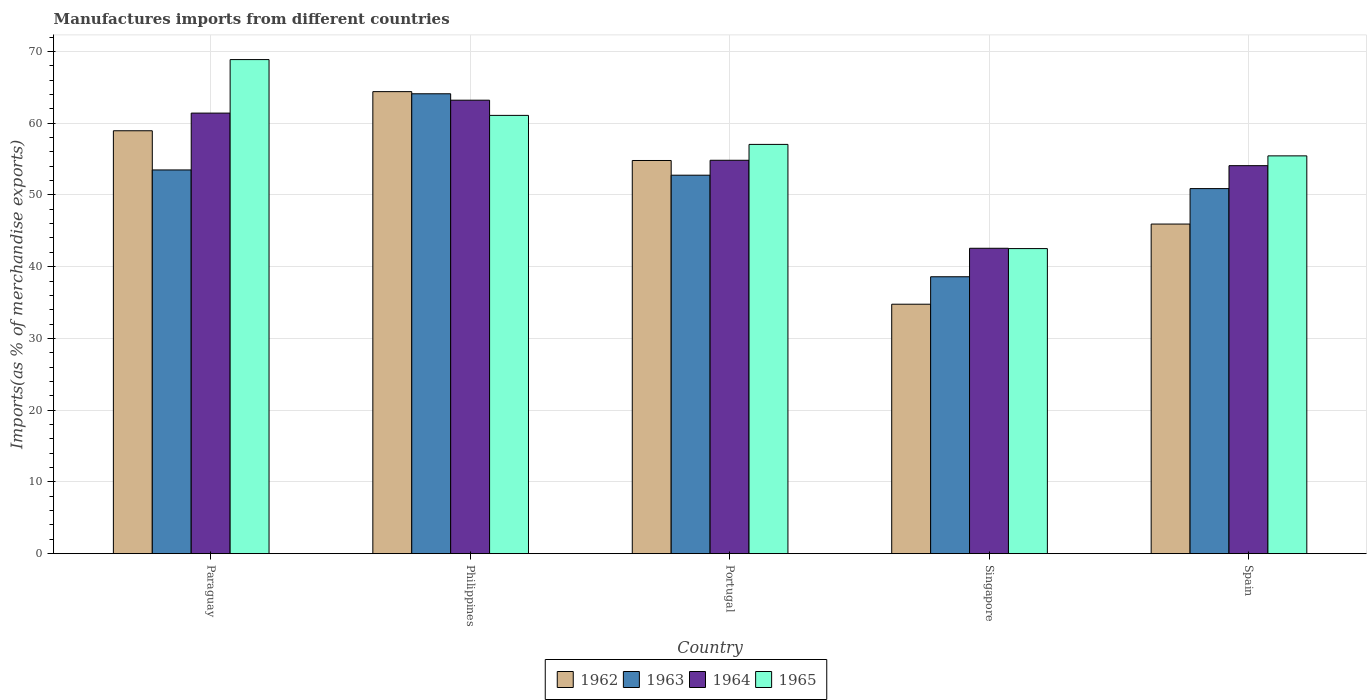How many different coloured bars are there?
Offer a very short reply. 4. How many groups of bars are there?
Keep it short and to the point. 5. Are the number of bars on each tick of the X-axis equal?
Give a very brief answer. Yes. How many bars are there on the 1st tick from the right?
Keep it short and to the point. 4. What is the label of the 5th group of bars from the left?
Provide a succinct answer. Spain. What is the percentage of imports to different countries in 1963 in Spain?
Your answer should be very brief. 50.88. Across all countries, what is the maximum percentage of imports to different countries in 1962?
Offer a terse response. 64.4. Across all countries, what is the minimum percentage of imports to different countries in 1963?
Ensure brevity in your answer.  38.6. In which country was the percentage of imports to different countries in 1965 maximum?
Give a very brief answer. Paraguay. In which country was the percentage of imports to different countries in 1964 minimum?
Offer a terse response. Singapore. What is the total percentage of imports to different countries in 1964 in the graph?
Offer a terse response. 276.08. What is the difference between the percentage of imports to different countries in 1963 in Portugal and that in Singapore?
Give a very brief answer. 14.16. What is the difference between the percentage of imports to different countries in 1964 in Singapore and the percentage of imports to different countries in 1963 in Portugal?
Ensure brevity in your answer.  -10.19. What is the average percentage of imports to different countries in 1962 per country?
Make the answer very short. 51.77. What is the difference between the percentage of imports to different countries of/in 1964 and percentage of imports to different countries of/in 1962 in Portugal?
Offer a very short reply. 0.03. In how many countries, is the percentage of imports to different countries in 1964 greater than 46 %?
Your answer should be very brief. 4. What is the ratio of the percentage of imports to different countries in 1963 in Portugal to that in Singapore?
Keep it short and to the point. 1.37. What is the difference between the highest and the second highest percentage of imports to different countries in 1965?
Provide a succinct answer. -11.82. What is the difference between the highest and the lowest percentage of imports to different countries in 1963?
Give a very brief answer. 25.5. In how many countries, is the percentage of imports to different countries in 1963 greater than the average percentage of imports to different countries in 1963 taken over all countries?
Your answer should be compact. 3. What does the 1st bar from the left in Philippines represents?
Provide a succinct answer. 1962. What does the 2nd bar from the right in Portugal represents?
Give a very brief answer. 1964. How many bars are there?
Offer a very short reply. 20. How many countries are there in the graph?
Offer a very short reply. 5. Are the values on the major ticks of Y-axis written in scientific E-notation?
Offer a very short reply. No. Does the graph contain any zero values?
Make the answer very short. No. Does the graph contain grids?
Provide a succinct answer. Yes. What is the title of the graph?
Offer a very short reply. Manufactures imports from different countries. Does "1989" appear as one of the legend labels in the graph?
Your answer should be compact. No. What is the label or title of the X-axis?
Your answer should be very brief. Country. What is the label or title of the Y-axis?
Make the answer very short. Imports(as % of merchandise exports). What is the Imports(as % of merchandise exports) in 1962 in Paraguay?
Offer a terse response. 58.94. What is the Imports(as % of merchandise exports) of 1963 in Paraguay?
Provide a succinct answer. 53.48. What is the Imports(as % of merchandise exports) of 1964 in Paraguay?
Offer a very short reply. 61.4. What is the Imports(as % of merchandise exports) in 1965 in Paraguay?
Keep it short and to the point. 68.86. What is the Imports(as % of merchandise exports) in 1962 in Philippines?
Provide a short and direct response. 64.4. What is the Imports(as % of merchandise exports) in 1963 in Philippines?
Your response must be concise. 64.1. What is the Imports(as % of merchandise exports) in 1964 in Philippines?
Your response must be concise. 63.2. What is the Imports(as % of merchandise exports) of 1965 in Philippines?
Offer a terse response. 61.09. What is the Imports(as % of merchandise exports) of 1962 in Portugal?
Offer a very short reply. 54.8. What is the Imports(as % of merchandise exports) of 1963 in Portugal?
Your answer should be compact. 52.75. What is the Imports(as % of merchandise exports) in 1964 in Portugal?
Provide a succinct answer. 54.83. What is the Imports(as % of merchandise exports) in 1965 in Portugal?
Keep it short and to the point. 57.04. What is the Imports(as % of merchandise exports) in 1962 in Singapore?
Offer a terse response. 34.77. What is the Imports(as % of merchandise exports) in 1963 in Singapore?
Give a very brief answer. 38.6. What is the Imports(as % of merchandise exports) of 1964 in Singapore?
Your answer should be very brief. 42.56. What is the Imports(as % of merchandise exports) of 1965 in Singapore?
Ensure brevity in your answer.  42.52. What is the Imports(as % of merchandise exports) of 1962 in Spain?
Your response must be concise. 45.94. What is the Imports(as % of merchandise exports) in 1963 in Spain?
Your answer should be very brief. 50.88. What is the Imports(as % of merchandise exports) of 1964 in Spain?
Provide a short and direct response. 54.08. What is the Imports(as % of merchandise exports) of 1965 in Spain?
Your answer should be very brief. 55.44. Across all countries, what is the maximum Imports(as % of merchandise exports) of 1962?
Ensure brevity in your answer.  64.4. Across all countries, what is the maximum Imports(as % of merchandise exports) of 1963?
Your response must be concise. 64.1. Across all countries, what is the maximum Imports(as % of merchandise exports) in 1964?
Your response must be concise. 63.2. Across all countries, what is the maximum Imports(as % of merchandise exports) in 1965?
Give a very brief answer. 68.86. Across all countries, what is the minimum Imports(as % of merchandise exports) of 1962?
Offer a terse response. 34.77. Across all countries, what is the minimum Imports(as % of merchandise exports) of 1963?
Your response must be concise. 38.6. Across all countries, what is the minimum Imports(as % of merchandise exports) in 1964?
Offer a very short reply. 42.56. Across all countries, what is the minimum Imports(as % of merchandise exports) in 1965?
Give a very brief answer. 42.52. What is the total Imports(as % of merchandise exports) of 1962 in the graph?
Keep it short and to the point. 258.85. What is the total Imports(as % of merchandise exports) of 1963 in the graph?
Ensure brevity in your answer.  259.81. What is the total Imports(as % of merchandise exports) of 1964 in the graph?
Provide a short and direct response. 276.08. What is the total Imports(as % of merchandise exports) of 1965 in the graph?
Give a very brief answer. 284.96. What is the difference between the Imports(as % of merchandise exports) of 1962 in Paraguay and that in Philippines?
Provide a short and direct response. -5.45. What is the difference between the Imports(as % of merchandise exports) in 1963 in Paraguay and that in Philippines?
Ensure brevity in your answer.  -10.62. What is the difference between the Imports(as % of merchandise exports) of 1964 in Paraguay and that in Philippines?
Your response must be concise. -1.8. What is the difference between the Imports(as % of merchandise exports) in 1965 in Paraguay and that in Philippines?
Your response must be concise. 7.78. What is the difference between the Imports(as % of merchandise exports) in 1962 in Paraguay and that in Portugal?
Make the answer very short. 4.15. What is the difference between the Imports(as % of merchandise exports) in 1963 in Paraguay and that in Portugal?
Provide a succinct answer. 0.73. What is the difference between the Imports(as % of merchandise exports) in 1964 in Paraguay and that in Portugal?
Offer a very short reply. 6.57. What is the difference between the Imports(as % of merchandise exports) in 1965 in Paraguay and that in Portugal?
Provide a short and direct response. 11.82. What is the difference between the Imports(as % of merchandise exports) in 1962 in Paraguay and that in Singapore?
Your response must be concise. 24.17. What is the difference between the Imports(as % of merchandise exports) of 1963 in Paraguay and that in Singapore?
Your answer should be compact. 14.89. What is the difference between the Imports(as % of merchandise exports) of 1964 in Paraguay and that in Singapore?
Your answer should be compact. 18.84. What is the difference between the Imports(as % of merchandise exports) of 1965 in Paraguay and that in Singapore?
Offer a very short reply. 26.34. What is the difference between the Imports(as % of merchandise exports) of 1962 in Paraguay and that in Spain?
Provide a succinct answer. 13. What is the difference between the Imports(as % of merchandise exports) in 1963 in Paraguay and that in Spain?
Your answer should be very brief. 2.6. What is the difference between the Imports(as % of merchandise exports) of 1964 in Paraguay and that in Spain?
Offer a terse response. 7.33. What is the difference between the Imports(as % of merchandise exports) of 1965 in Paraguay and that in Spain?
Provide a succinct answer. 13.42. What is the difference between the Imports(as % of merchandise exports) in 1962 in Philippines and that in Portugal?
Provide a short and direct response. 9.6. What is the difference between the Imports(as % of merchandise exports) of 1963 in Philippines and that in Portugal?
Provide a succinct answer. 11.35. What is the difference between the Imports(as % of merchandise exports) of 1964 in Philippines and that in Portugal?
Keep it short and to the point. 8.37. What is the difference between the Imports(as % of merchandise exports) of 1965 in Philippines and that in Portugal?
Make the answer very short. 4.04. What is the difference between the Imports(as % of merchandise exports) of 1962 in Philippines and that in Singapore?
Keep it short and to the point. 29.63. What is the difference between the Imports(as % of merchandise exports) of 1963 in Philippines and that in Singapore?
Provide a short and direct response. 25.5. What is the difference between the Imports(as % of merchandise exports) of 1964 in Philippines and that in Singapore?
Provide a succinct answer. 20.64. What is the difference between the Imports(as % of merchandise exports) in 1965 in Philippines and that in Singapore?
Give a very brief answer. 18.57. What is the difference between the Imports(as % of merchandise exports) in 1962 in Philippines and that in Spain?
Your answer should be compact. 18.46. What is the difference between the Imports(as % of merchandise exports) in 1963 in Philippines and that in Spain?
Your response must be concise. 13.22. What is the difference between the Imports(as % of merchandise exports) in 1964 in Philippines and that in Spain?
Your answer should be very brief. 9.12. What is the difference between the Imports(as % of merchandise exports) of 1965 in Philippines and that in Spain?
Offer a very short reply. 5.64. What is the difference between the Imports(as % of merchandise exports) of 1962 in Portugal and that in Singapore?
Your response must be concise. 20.03. What is the difference between the Imports(as % of merchandise exports) in 1963 in Portugal and that in Singapore?
Your answer should be very brief. 14.16. What is the difference between the Imports(as % of merchandise exports) in 1964 in Portugal and that in Singapore?
Give a very brief answer. 12.27. What is the difference between the Imports(as % of merchandise exports) of 1965 in Portugal and that in Singapore?
Your response must be concise. 14.52. What is the difference between the Imports(as % of merchandise exports) in 1962 in Portugal and that in Spain?
Ensure brevity in your answer.  8.86. What is the difference between the Imports(as % of merchandise exports) of 1963 in Portugal and that in Spain?
Your answer should be compact. 1.87. What is the difference between the Imports(as % of merchandise exports) in 1964 in Portugal and that in Spain?
Your answer should be very brief. 0.75. What is the difference between the Imports(as % of merchandise exports) of 1965 in Portugal and that in Spain?
Provide a succinct answer. 1.6. What is the difference between the Imports(as % of merchandise exports) of 1962 in Singapore and that in Spain?
Your response must be concise. -11.17. What is the difference between the Imports(as % of merchandise exports) of 1963 in Singapore and that in Spain?
Provide a succinct answer. -12.29. What is the difference between the Imports(as % of merchandise exports) in 1964 in Singapore and that in Spain?
Offer a very short reply. -11.51. What is the difference between the Imports(as % of merchandise exports) in 1965 in Singapore and that in Spain?
Make the answer very short. -12.92. What is the difference between the Imports(as % of merchandise exports) in 1962 in Paraguay and the Imports(as % of merchandise exports) in 1963 in Philippines?
Provide a short and direct response. -5.15. What is the difference between the Imports(as % of merchandise exports) of 1962 in Paraguay and the Imports(as % of merchandise exports) of 1964 in Philippines?
Your answer should be compact. -4.26. What is the difference between the Imports(as % of merchandise exports) of 1962 in Paraguay and the Imports(as % of merchandise exports) of 1965 in Philippines?
Your answer should be compact. -2.14. What is the difference between the Imports(as % of merchandise exports) of 1963 in Paraguay and the Imports(as % of merchandise exports) of 1964 in Philippines?
Provide a succinct answer. -9.72. What is the difference between the Imports(as % of merchandise exports) of 1963 in Paraguay and the Imports(as % of merchandise exports) of 1965 in Philippines?
Offer a terse response. -7.61. What is the difference between the Imports(as % of merchandise exports) of 1964 in Paraguay and the Imports(as % of merchandise exports) of 1965 in Philippines?
Offer a very short reply. 0.32. What is the difference between the Imports(as % of merchandise exports) in 1962 in Paraguay and the Imports(as % of merchandise exports) in 1963 in Portugal?
Keep it short and to the point. 6.19. What is the difference between the Imports(as % of merchandise exports) of 1962 in Paraguay and the Imports(as % of merchandise exports) of 1964 in Portugal?
Ensure brevity in your answer.  4.11. What is the difference between the Imports(as % of merchandise exports) in 1962 in Paraguay and the Imports(as % of merchandise exports) in 1965 in Portugal?
Offer a terse response. 1.9. What is the difference between the Imports(as % of merchandise exports) of 1963 in Paraguay and the Imports(as % of merchandise exports) of 1964 in Portugal?
Give a very brief answer. -1.35. What is the difference between the Imports(as % of merchandise exports) of 1963 in Paraguay and the Imports(as % of merchandise exports) of 1965 in Portugal?
Your response must be concise. -3.56. What is the difference between the Imports(as % of merchandise exports) in 1964 in Paraguay and the Imports(as % of merchandise exports) in 1965 in Portugal?
Ensure brevity in your answer.  4.36. What is the difference between the Imports(as % of merchandise exports) of 1962 in Paraguay and the Imports(as % of merchandise exports) of 1963 in Singapore?
Make the answer very short. 20.35. What is the difference between the Imports(as % of merchandise exports) in 1962 in Paraguay and the Imports(as % of merchandise exports) in 1964 in Singapore?
Give a very brief answer. 16.38. What is the difference between the Imports(as % of merchandise exports) of 1962 in Paraguay and the Imports(as % of merchandise exports) of 1965 in Singapore?
Your answer should be very brief. 16.42. What is the difference between the Imports(as % of merchandise exports) in 1963 in Paraguay and the Imports(as % of merchandise exports) in 1964 in Singapore?
Make the answer very short. 10.92. What is the difference between the Imports(as % of merchandise exports) of 1963 in Paraguay and the Imports(as % of merchandise exports) of 1965 in Singapore?
Ensure brevity in your answer.  10.96. What is the difference between the Imports(as % of merchandise exports) in 1964 in Paraguay and the Imports(as % of merchandise exports) in 1965 in Singapore?
Keep it short and to the point. 18.88. What is the difference between the Imports(as % of merchandise exports) of 1962 in Paraguay and the Imports(as % of merchandise exports) of 1963 in Spain?
Offer a very short reply. 8.06. What is the difference between the Imports(as % of merchandise exports) in 1962 in Paraguay and the Imports(as % of merchandise exports) in 1964 in Spain?
Your answer should be very brief. 4.87. What is the difference between the Imports(as % of merchandise exports) in 1962 in Paraguay and the Imports(as % of merchandise exports) in 1965 in Spain?
Offer a terse response. 3.5. What is the difference between the Imports(as % of merchandise exports) of 1963 in Paraguay and the Imports(as % of merchandise exports) of 1964 in Spain?
Provide a succinct answer. -0.6. What is the difference between the Imports(as % of merchandise exports) of 1963 in Paraguay and the Imports(as % of merchandise exports) of 1965 in Spain?
Your answer should be compact. -1.96. What is the difference between the Imports(as % of merchandise exports) in 1964 in Paraguay and the Imports(as % of merchandise exports) in 1965 in Spain?
Your answer should be very brief. 5.96. What is the difference between the Imports(as % of merchandise exports) of 1962 in Philippines and the Imports(as % of merchandise exports) of 1963 in Portugal?
Your answer should be very brief. 11.65. What is the difference between the Imports(as % of merchandise exports) of 1962 in Philippines and the Imports(as % of merchandise exports) of 1964 in Portugal?
Give a very brief answer. 9.57. What is the difference between the Imports(as % of merchandise exports) in 1962 in Philippines and the Imports(as % of merchandise exports) in 1965 in Portugal?
Your response must be concise. 7.35. What is the difference between the Imports(as % of merchandise exports) of 1963 in Philippines and the Imports(as % of merchandise exports) of 1964 in Portugal?
Offer a terse response. 9.27. What is the difference between the Imports(as % of merchandise exports) of 1963 in Philippines and the Imports(as % of merchandise exports) of 1965 in Portugal?
Give a very brief answer. 7.05. What is the difference between the Imports(as % of merchandise exports) of 1964 in Philippines and the Imports(as % of merchandise exports) of 1965 in Portugal?
Your answer should be very brief. 6.16. What is the difference between the Imports(as % of merchandise exports) of 1962 in Philippines and the Imports(as % of merchandise exports) of 1963 in Singapore?
Give a very brief answer. 25.8. What is the difference between the Imports(as % of merchandise exports) in 1962 in Philippines and the Imports(as % of merchandise exports) in 1964 in Singapore?
Keep it short and to the point. 21.83. What is the difference between the Imports(as % of merchandise exports) of 1962 in Philippines and the Imports(as % of merchandise exports) of 1965 in Singapore?
Give a very brief answer. 21.87. What is the difference between the Imports(as % of merchandise exports) in 1963 in Philippines and the Imports(as % of merchandise exports) in 1964 in Singapore?
Your answer should be compact. 21.53. What is the difference between the Imports(as % of merchandise exports) in 1963 in Philippines and the Imports(as % of merchandise exports) in 1965 in Singapore?
Your answer should be very brief. 21.58. What is the difference between the Imports(as % of merchandise exports) of 1964 in Philippines and the Imports(as % of merchandise exports) of 1965 in Singapore?
Provide a short and direct response. 20.68. What is the difference between the Imports(as % of merchandise exports) of 1962 in Philippines and the Imports(as % of merchandise exports) of 1963 in Spain?
Your answer should be very brief. 13.51. What is the difference between the Imports(as % of merchandise exports) in 1962 in Philippines and the Imports(as % of merchandise exports) in 1964 in Spain?
Offer a very short reply. 10.32. What is the difference between the Imports(as % of merchandise exports) of 1962 in Philippines and the Imports(as % of merchandise exports) of 1965 in Spain?
Offer a very short reply. 8.95. What is the difference between the Imports(as % of merchandise exports) of 1963 in Philippines and the Imports(as % of merchandise exports) of 1964 in Spain?
Offer a very short reply. 10.02. What is the difference between the Imports(as % of merchandise exports) of 1963 in Philippines and the Imports(as % of merchandise exports) of 1965 in Spain?
Give a very brief answer. 8.65. What is the difference between the Imports(as % of merchandise exports) of 1964 in Philippines and the Imports(as % of merchandise exports) of 1965 in Spain?
Your response must be concise. 7.76. What is the difference between the Imports(as % of merchandise exports) of 1962 in Portugal and the Imports(as % of merchandise exports) of 1963 in Singapore?
Your answer should be very brief. 16.2. What is the difference between the Imports(as % of merchandise exports) in 1962 in Portugal and the Imports(as % of merchandise exports) in 1964 in Singapore?
Offer a very short reply. 12.23. What is the difference between the Imports(as % of merchandise exports) in 1962 in Portugal and the Imports(as % of merchandise exports) in 1965 in Singapore?
Offer a very short reply. 12.28. What is the difference between the Imports(as % of merchandise exports) of 1963 in Portugal and the Imports(as % of merchandise exports) of 1964 in Singapore?
Your answer should be very brief. 10.19. What is the difference between the Imports(as % of merchandise exports) of 1963 in Portugal and the Imports(as % of merchandise exports) of 1965 in Singapore?
Keep it short and to the point. 10.23. What is the difference between the Imports(as % of merchandise exports) in 1964 in Portugal and the Imports(as % of merchandise exports) in 1965 in Singapore?
Give a very brief answer. 12.31. What is the difference between the Imports(as % of merchandise exports) in 1962 in Portugal and the Imports(as % of merchandise exports) in 1963 in Spain?
Make the answer very short. 3.92. What is the difference between the Imports(as % of merchandise exports) in 1962 in Portugal and the Imports(as % of merchandise exports) in 1964 in Spain?
Ensure brevity in your answer.  0.72. What is the difference between the Imports(as % of merchandise exports) of 1962 in Portugal and the Imports(as % of merchandise exports) of 1965 in Spain?
Give a very brief answer. -0.65. What is the difference between the Imports(as % of merchandise exports) in 1963 in Portugal and the Imports(as % of merchandise exports) in 1964 in Spain?
Give a very brief answer. -1.33. What is the difference between the Imports(as % of merchandise exports) of 1963 in Portugal and the Imports(as % of merchandise exports) of 1965 in Spain?
Your answer should be compact. -2.69. What is the difference between the Imports(as % of merchandise exports) of 1964 in Portugal and the Imports(as % of merchandise exports) of 1965 in Spain?
Ensure brevity in your answer.  -0.61. What is the difference between the Imports(as % of merchandise exports) in 1962 in Singapore and the Imports(as % of merchandise exports) in 1963 in Spain?
Ensure brevity in your answer.  -16.11. What is the difference between the Imports(as % of merchandise exports) in 1962 in Singapore and the Imports(as % of merchandise exports) in 1964 in Spain?
Offer a terse response. -19.31. What is the difference between the Imports(as % of merchandise exports) of 1962 in Singapore and the Imports(as % of merchandise exports) of 1965 in Spain?
Your answer should be compact. -20.68. What is the difference between the Imports(as % of merchandise exports) of 1963 in Singapore and the Imports(as % of merchandise exports) of 1964 in Spain?
Your answer should be compact. -15.48. What is the difference between the Imports(as % of merchandise exports) in 1963 in Singapore and the Imports(as % of merchandise exports) in 1965 in Spain?
Offer a very short reply. -16.85. What is the difference between the Imports(as % of merchandise exports) in 1964 in Singapore and the Imports(as % of merchandise exports) in 1965 in Spain?
Provide a succinct answer. -12.88. What is the average Imports(as % of merchandise exports) of 1962 per country?
Provide a succinct answer. 51.77. What is the average Imports(as % of merchandise exports) in 1963 per country?
Make the answer very short. 51.96. What is the average Imports(as % of merchandise exports) in 1964 per country?
Ensure brevity in your answer.  55.22. What is the average Imports(as % of merchandise exports) of 1965 per country?
Your response must be concise. 56.99. What is the difference between the Imports(as % of merchandise exports) of 1962 and Imports(as % of merchandise exports) of 1963 in Paraguay?
Ensure brevity in your answer.  5.46. What is the difference between the Imports(as % of merchandise exports) of 1962 and Imports(as % of merchandise exports) of 1964 in Paraguay?
Offer a very short reply. -2.46. What is the difference between the Imports(as % of merchandise exports) of 1962 and Imports(as % of merchandise exports) of 1965 in Paraguay?
Your answer should be compact. -9.92. What is the difference between the Imports(as % of merchandise exports) of 1963 and Imports(as % of merchandise exports) of 1964 in Paraguay?
Ensure brevity in your answer.  -7.92. What is the difference between the Imports(as % of merchandise exports) of 1963 and Imports(as % of merchandise exports) of 1965 in Paraguay?
Offer a very short reply. -15.38. What is the difference between the Imports(as % of merchandise exports) in 1964 and Imports(as % of merchandise exports) in 1965 in Paraguay?
Your answer should be compact. -7.46. What is the difference between the Imports(as % of merchandise exports) in 1962 and Imports(as % of merchandise exports) in 1963 in Philippines?
Your answer should be compact. 0.3. What is the difference between the Imports(as % of merchandise exports) in 1962 and Imports(as % of merchandise exports) in 1964 in Philippines?
Give a very brief answer. 1.19. What is the difference between the Imports(as % of merchandise exports) of 1962 and Imports(as % of merchandise exports) of 1965 in Philippines?
Your answer should be compact. 3.31. What is the difference between the Imports(as % of merchandise exports) in 1963 and Imports(as % of merchandise exports) in 1964 in Philippines?
Your answer should be very brief. 0.89. What is the difference between the Imports(as % of merchandise exports) of 1963 and Imports(as % of merchandise exports) of 1965 in Philippines?
Offer a terse response. 3.01. What is the difference between the Imports(as % of merchandise exports) in 1964 and Imports(as % of merchandise exports) in 1965 in Philippines?
Give a very brief answer. 2.12. What is the difference between the Imports(as % of merchandise exports) in 1962 and Imports(as % of merchandise exports) in 1963 in Portugal?
Offer a terse response. 2.05. What is the difference between the Imports(as % of merchandise exports) of 1962 and Imports(as % of merchandise exports) of 1964 in Portugal?
Keep it short and to the point. -0.03. What is the difference between the Imports(as % of merchandise exports) in 1962 and Imports(as % of merchandise exports) in 1965 in Portugal?
Offer a terse response. -2.24. What is the difference between the Imports(as % of merchandise exports) of 1963 and Imports(as % of merchandise exports) of 1964 in Portugal?
Make the answer very short. -2.08. What is the difference between the Imports(as % of merchandise exports) of 1963 and Imports(as % of merchandise exports) of 1965 in Portugal?
Your answer should be compact. -4.29. What is the difference between the Imports(as % of merchandise exports) in 1964 and Imports(as % of merchandise exports) in 1965 in Portugal?
Give a very brief answer. -2.21. What is the difference between the Imports(as % of merchandise exports) of 1962 and Imports(as % of merchandise exports) of 1963 in Singapore?
Keep it short and to the point. -3.83. What is the difference between the Imports(as % of merchandise exports) in 1962 and Imports(as % of merchandise exports) in 1964 in Singapore?
Make the answer very short. -7.8. What is the difference between the Imports(as % of merchandise exports) of 1962 and Imports(as % of merchandise exports) of 1965 in Singapore?
Offer a very short reply. -7.75. What is the difference between the Imports(as % of merchandise exports) in 1963 and Imports(as % of merchandise exports) in 1964 in Singapore?
Your answer should be very brief. -3.97. What is the difference between the Imports(as % of merchandise exports) in 1963 and Imports(as % of merchandise exports) in 1965 in Singapore?
Keep it short and to the point. -3.93. What is the difference between the Imports(as % of merchandise exports) of 1964 and Imports(as % of merchandise exports) of 1965 in Singapore?
Provide a short and direct response. 0.04. What is the difference between the Imports(as % of merchandise exports) of 1962 and Imports(as % of merchandise exports) of 1963 in Spain?
Give a very brief answer. -4.94. What is the difference between the Imports(as % of merchandise exports) in 1962 and Imports(as % of merchandise exports) in 1964 in Spain?
Your answer should be compact. -8.14. What is the difference between the Imports(as % of merchandise exports) of 1962 and Imports(as % of merchandise exports) of 1965 in Spain?
Offer a terse response. -9.51. What is the difference between the Imports(as % of merchandise exports) in 1963 and Imports(as % of merchandise exports) in 1964 in Spain?
Make the answer very short. -3.2. What is the difference between the Imports(as % of merchandise exports) in 1963 and Imports(as % of merchandise exports) in 1965 in Spain?
Provide a succinct answer. -4.56. What is the difference between the Imports(as % of merchandise exports) of 1964 and Imports(as % of merchandise exports) of 1965 in Spain?
Provide a short and direct response. -1.37. What is the ratio of the Imports(as % of merchandise exports) in 1962 in Paraguay to that in Philippines?
Your response must be concise. 0.92. What is the ratio of the Imports(as % of merchandise exports) of 1963 in Paraguay to that in Philippines?
Make the answer very short. 0.83. What is the ratio of the Imports(as % of merchandise exports) in 1964 in Paraguay to that in Philippines?
Keep it short and to the point. 0.97. What is the ratio of the Imports(as % of merchandise exports) of 1965 in Paraguay to that in Philippines?
Your response must be concise. 1.13. What is the ratio of the Imports(as % of merchandise exports) in 1962 in Paraguay to that in Portugal?
Give a very brief answer. 1.08. What is the ratio of the Imports(as % of merchandise exports) of 1963 in Paraguay to that in Portugal?
Keep it short and to the point. 1.01. What is the ratio of the Imports(as % of merchandise exports) of 1964 in Paraguay to that in Portugal?
Your response must be concise. 1.12. What is the ratio of the Imports(as % of merchandise exports) in 1965 in Paraguay to that in Portugal?
Offer a very short reply. 1.21. What is the ratio of the Imports(as % of merchandise exports) of 1962 in Paraguay to that in Singapore?
Your answer should be compact. 1.7. What is the ratio of the Imports(as % of merchandise exports) in 1963 in Paraguay to that in Singapore?
Provide a short and direct response. 1.39. What is the ratio of the Imports(as % of merchandise exports) in 1964 in Paraguay to that in Singapore?
Provide a succinct answer. 1.44. What is the ratio of the Imports(as % of merchandise exports) in 1965 in Paraguay to that in Singapore?
Offer a very short reply. 1.62. What is the ratio of the Imports(as % of merchandise exports) in 1962 in Paraguay to that in Spain?
Your answer should be very brief. 1.28. What is the ratio of the Imports(as % of merchandise exports) in 1963 in Paraguay to that in Spain?
Your answer should be compact. 1.05. What is the ratio of the Imports(as % of merchandise exports) in 1964 in Paraguay to that in Spain?
Keep it short and to the point. 1.14. What is the ratio of the Imports(as % of merchandise exports) of 1965 in Paraguay to that in Spain?
Your answer should be compact. 1.24. What is the ratio of the Imports(as % of merchandise exports) of 1962 in Philippines to that in Portugal?
Offer a terse response. 1.18. What is the ratio of the Imports(as % of merchandise exports) in 1963 in Philippines to that in Portugal?
Offer a terse response. 1.22. What is the ratio of the Imports(as % of merchandise exports) in 1964 in Philippines to that in Portugal?
Your answer should be very brief. 1.15. What is the ratio of the Imports(as % of merchandise exports) of 1965 in Philippines to that in Portugal?
Offer a very short reply. 1.07. What is the ratio of the Imports(as % of merchandise exports) of 1962 in Philippines to that in Singapore?
Provide a short and direct response. 1.85. What is the ratio of the Imports(as % of merchandise exports) of 1963 in Philippines to that in Singapore?
Make the answer very short. 1.66. What is the ratio of the Imports(as % of merchandise exports) of 1964 in Philippines to that in Singapore?
Your answer should be very brief. 1.48. What is the ratio of the Imports(as % of merchandise exports) of 1965 in Philippines to that in Singapore?
Provide a succinct answer. 1.44. What is the ratio of the Imports(as % of merchandise exports) in 1962 in Philippines to that in Spain?
Your answer should be compact. 1.4. What is the ratio of the Imports(as % of merchandise exports) of 1963 in Philippines to that in Spain?
Ensure brevity in your answer.  1.26. What is the ratio of the Imports(as % of merchandise exports) of 1964 in Philippines to that in Spain?
Ensure brevity in your answer.  1.17. What is the ratio of the Imports(as % of merchandise exports) of 1965 in Philippines to that in Spain?
Provide a succinct answer. 1.1. What is the ratio of the Imports(as % of merchandise exports) in 1962 in Portugal to that in Singapore?
Make the answer very short. 1.58. What is the ratio of the Imports(as % of merchandise exports) of 1963 in Portugal to that in Singapore?
Your response must be concise. 1.37. What is the ratio of the Imports(as % of merchandise exports) in 1964 in Portugal to that in Singapore?
Give a very brief answer. 1.29. What is the ratio of the Imports(as % of merchandise exports) in 1965 in Portugal to that in Singapore?
Your answer should be compact. 1.34. What is the ratio of the Imports(as % of merchandise exports) of 1962 in Portugal to that in Spain?
Your response must be concise. 1.19. What is the ratio of the Imports(as % of merchandise exports) in 1963 in Portugal to that in Spain?
Keep it short and to the point. 1.04. What is the ratio of the Imports(as % of merchandise exports) of 1964 in Portugal to that in Spain?
Offer a terse response. 1.01. What is the ratio of the Imports(as % of merchandise exports) of 1965 in Portugal to that in Spain?
Offer a terse response. 1.03. What is the ratio of the Imports(as % of merchandise exports) of 1962 in Singapore to that in Spain?
Keep it short and to the point. 0.76. What is the ratio of the Imports(as % of merchandise exports) in 1963 in Singapore to that in Spain?
Ensure brevity in your answer.  0.76. What is the ratio of the Imports(as % of merchandise exports) in 1964 in Singapore to that in Spain?
Provide a succinct answer. 0.79. What is the ratio of the Imports(as % of merchandise exports) in 1965 in Singapore to that in Spain?
Provide a succinct answer. 0.77. What is the difference between the highest and the second highest Imports(as % of merchandise exports) in 1962?
Your answer should be very brief. 5.45. What is the difference between the highest and the second highest Imports(as % of merchandise exports) in 1963?
Keep it short and to the point. 10.62. What is the difference between the highest and the second highest Imports(as % of merchandise exports) in 1964?
Make the answer very short. 1.8. What is the difference between the highest and the second highest Imports(as % of merchandise exports) in 1965?
Ensure brevity in your answer.  7.78. What is the difference between the highest and the lowest Imports(as % of merchandise exports) of 1962?
Keep it short and to the point. 29.63. What is the difference between the highest and the lowest Imports(as % of merchandise exports) of 1963?
Offer a terse response. 25.5. What is the difference between the highest and the lowest Imports(as % of merchandise exports) in 1964?
Your response must be concise. 20.64. What is the difference between the highest and the lowest Imports(as % of merchandise exports) of 1965?
Ensure brevity in your answer.  26.34. 